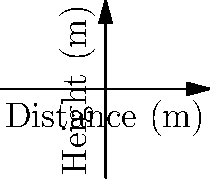Based on the trajectory plots of three different rugby ball kicks, which kick would be most suitable for a long-distance clearance? To determine which kick is most suitable for a long-distance clearance, we need to analyze the trajectory of each kick:

1. Kick A (blue line):
   - Reaches a moderate height
   - Travels about 20 meters in distance

2. Kick B (red line):
   - Has a lower arc compared to Kick A
   - Travels the furthest, reaching about 30 meters

3. Kick C (green line):
   - Has the highest arc
   - Travels the shortest distance, only about 10 meters

For a long-distance clearance in rugby, we want a kick that travels the furthest horizontally. This allows the team to gain more ground and push the opposition back.

Kick B travels the furthest distance (about 30 meters) with a relatively low arc. This combination of distance and trajectory is ideal for a long-distance clearance, as it gives the ball more time in the air while covering maximum distance.

Kick A could be suitable for a medium-distance kick, while Kick C might be more appropriate for a high, short kick to contest possession.
Answer: Kick B 